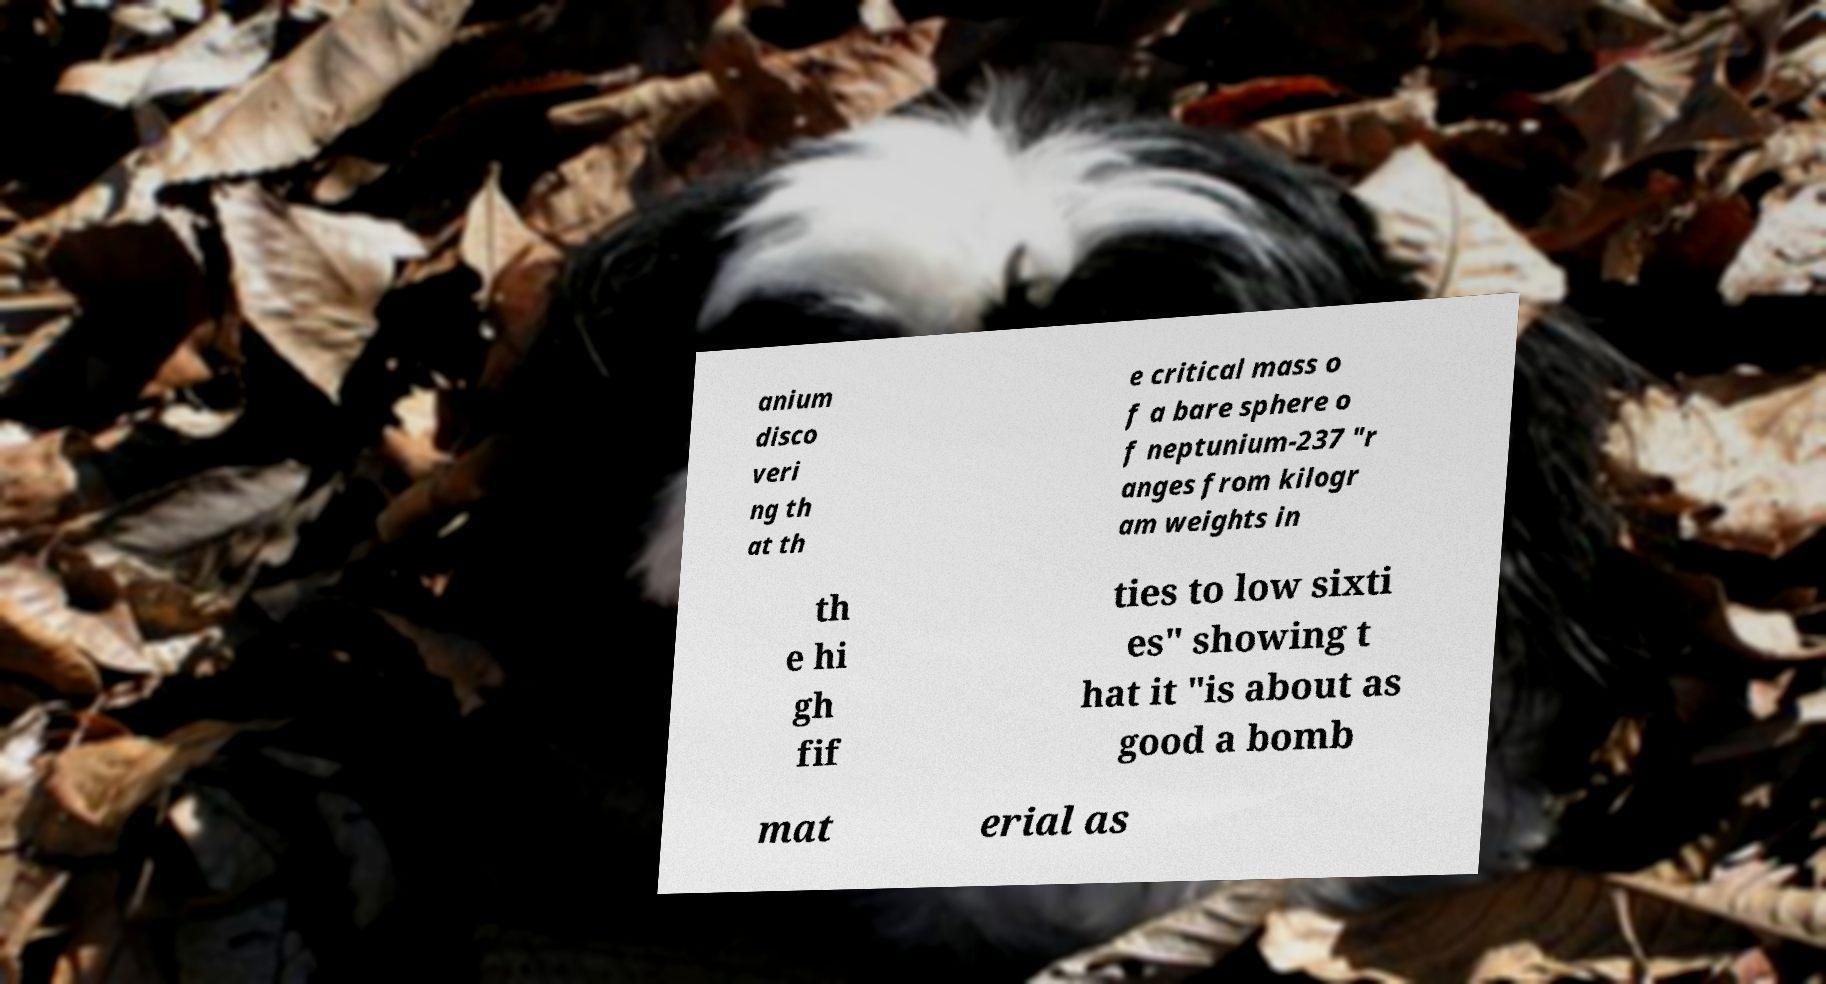What messages or text are displayed in this image? I need them in a readable, typed format. anium disco veri ng th at th e critical mass o f a bare sphere o f neptunium-237 "r anges from kilogr am weights in th e hi gh fif ties to low sixti es" showing t hat it "is about as good a bomb mat erial as 